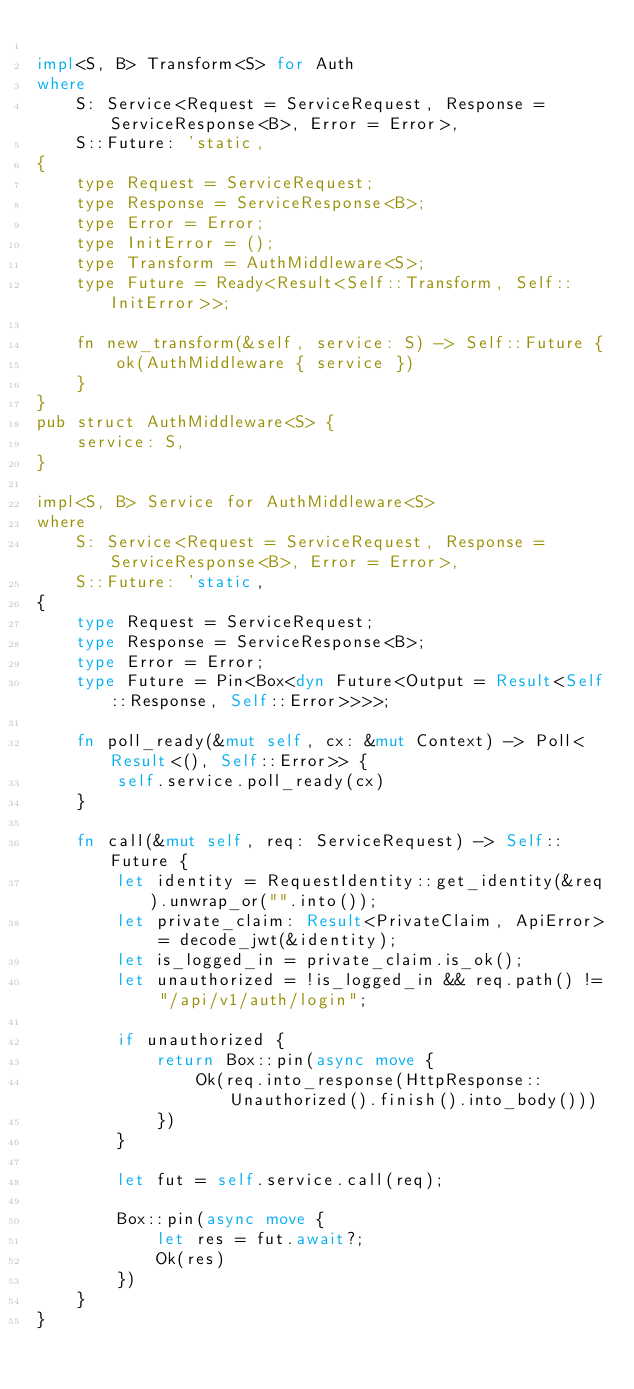<code> <loc_0><loc_0><loc_500><loc_500><_Rust_>
impl<S, B> Transform<S> for Auth
where
    S: Service<Request = ServiceRequest, Response = ServiceResponse<B>, Error = Error>,
    S::Future: 'static,
{
    type Request = ServiceRequest;
    type Response = ServiceResponse<B>;
    type Error = Error;
    type InitError = ();
    type Transform = AuthMiddleware<S>;
    type Future = Ready<Result<Self::Transform, Self::InitError>>;

    fn new_transform(&self, service: S) -> Self::Future {
        ok(AuthMiddleware { service })
    }
}
pub struct AuthMiddleware<S> {
    service: S,
}

impl<S, B> Service for AuthMiddleware<S>
where
    S: Service<Request = ServiceRequest, Response = ServiceResponse<B>, Error = Error>,
    S::Future: 'static,
{
    type Request = ServiceRequest;
    type Response = ServiceResponse<B>;
    type Error = Error;
    type Future = Pin<Box<dyn Future<Output = Result<Self::Response, Self::Error>>>>;

    fn poll_ready(&mut self, cx: &mut Context) -> Poll<Result<(), Self::Error>> {        
        self.service.poll_ready(cx)
    }

    fn call(&mut self, req: ServiceRequest) -> Self::Future {
        let identity = RequestIdentity::get_identity(&req).unwrap_or("".into());
        let private_claim: Result<PrivateClaim, ApiError> = decode_jwt(&identity);
        let is_logged_in = private_claim.is_ok();
        let unauthorized = !is_logged_in && req.path() != "/api/v1/auth/login";

        if unauthorized {
            return Box::pin(async move {
                Ok(req.into_response(HttpResponse::Unauthorized().finish().into_body()))
            })
        }

        let fut = self.service.call(req);

        Box::pin(async move {
            let res = fut.await?;
            Ok(res)
        })
    }
}
</code> 